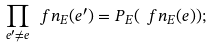Convert formula to latex. <formula><loc_0><loc_0><loc_500><loc_500>\prod _ { e ^ { \prime } \neq e } \ f n _ { E } ( e ^ { \prime } ) = P _ { E } ( \ f n _ { E } ( e ) ) ;</formula> 